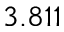Convert formula to latex. <formula><loc_0><loc_0><loc_500><loc_500>3 . 8 1 1</formula> 